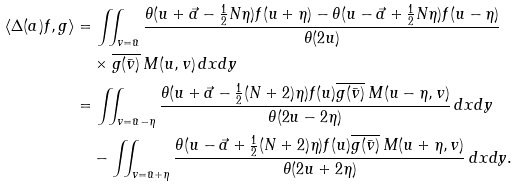<formula> <loc_0><loc_0><loc_500><loc_500>\langle \Delta ( a ) f , g \rangle & = \iint _ { v = \bar { u } } \frac { \theta ( u + \vec { a } - \frac { 1 } { 2 } N \eta ) f ( u + \eta ) - \theta ( u - \vec { a } + \frac { 1 } { 2 } N \eta ) f ( u - \eta ) } { \theta ( 2 u ) } \\ & \quad \times \overline { g ( \bar { v } ) } \, M ( u , v ) \, d x d y \\ & = \iint _ { v = \bar { u } - \eta } \frac { \theta ( u + \vec { a } - \frac { 1 } { 2 } ( N + 2 ) \eta ) f ( u ) \overline { g ( \bar { v } ) } \, M ( u - \eta , v ) } { \theta ( 2 u - 2 \eta ) } \, d x d y \\ & \quad - \iint _ { v = \bar { u } + \eta } \frac { \theta ( u - \vec { a } + \frac { 1 } { 2 } ( N + 2 ) \eta ) f ( u ) \overline { g ( \bar { v } ) } \, M ( u + \eta , v ) } { \theta ( 2 u + 2 \eta ) } \, d x d y .</formula> 